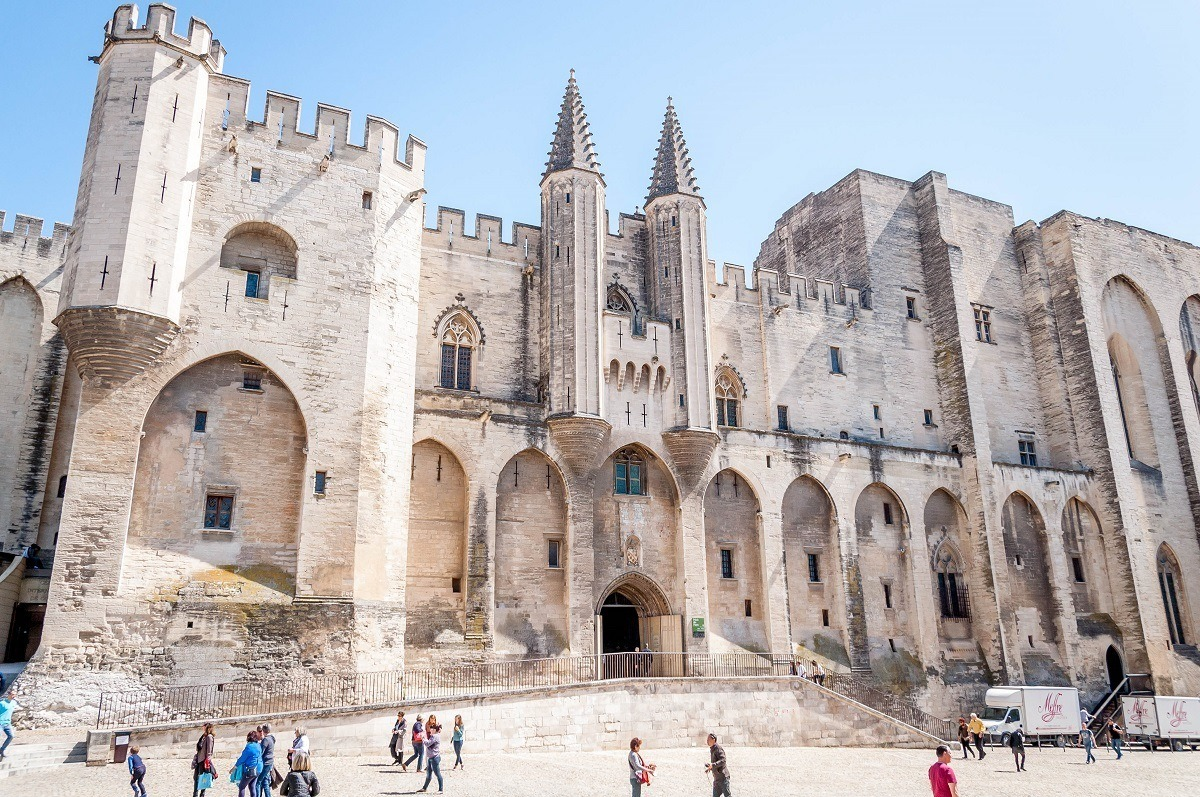What are some architectural details visible in the palace? The Papal Palace showcases an array of architectural details quintessential to medieval Gothic design. Notably, the twin spires protruding towards the sky are a striking feature, symbolizing the thrust towards the heavens typical in Gothic architecture. The fortress-like structure has several arched windows and entrances, with buttresses reinforcing the walls. The large, arched entrance is reminiscent of grand medieval portals, designed to both impress and intimidate. The detailed stone masonry, particularly around the window frames and doorways, adds an element of intricate craftsmanship to the otherwise robust and imposing edifice. 